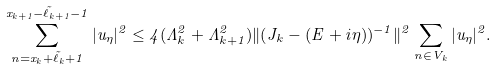Convert formula to latex. <formula><loc_0><loc_0><loc_500><loc_500>\sum _ { n = x _ { k } + \tilde { \ell } _ { k } + 1 } ^ { x _ { k + 1 } - \tilde { \ell } _ { k + 1 } - 1 } | u _ { \eta } | ^ { 2 } \leq 4 ( \Lambda _ { k } ^ { 2 } + \Lambda _ { k + 1 } ^ { 2 } ) \| ( J _ { k } - ( E + i \eta ) ) ^ { - 1 } \| ^ { 2 } \sum _ { n \in V _ { k } } | u _ { \eta } | ^ { 2 } .</formula> 